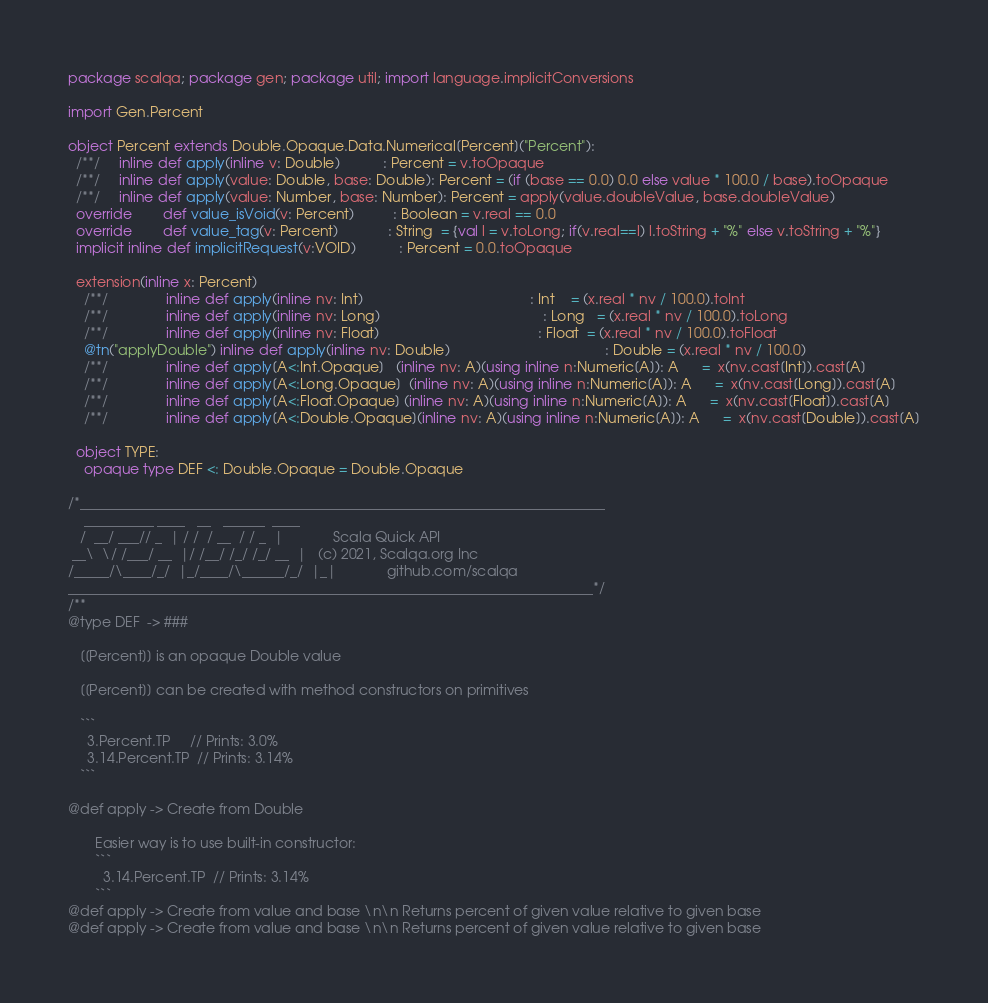<code> <loc_0><loc_0><loc_500><loc_500><_Scala_>package scalqa; package gen; package util; import language.implicitConversions

import Gen.Percent

object Percent extends Double.Opaque.Data.Numerical[Percent]("Percent"):
  /**/     inline def apply(inline v: Double)           : Percent = v.toOpaque
  /**/     inline def apply(value: Double, base: Double): Percent = (if (base == 0.0) 0.0 else value * 100.0 / base).toOpaque
  /**/     inline def apply(value: Number, base: Number): Percent = apply(value.doubleValue, base.doubleValue)
  override        def value_isVoid(v: Percent)          : Boolean = v.real == 0.0
  override        def value_tag(v: Percent)             : String  = {val l = v.toLong; if(v.real==l) l.toString + "%" else v.toString + "%"}
  implicit inline def implicitRequest(v:VOID)           : Percent = 0.0.toOpaque

  extension(inline x: Percent)
    /**/               inline def apply(inline nv: Int)                                           : Int    = (x.real * nv / 100.0).toInt
    /**/               inline def apply(inline nv: Long)                                          : Long   = (x.real * nv / 100.0).toLong
    /**/               inline def apply(inline nv: Float)                                         : Float  = (x.real * nv / 100.0).toFloat
    @tn("applyDouble") inline def apply(inline nv: Double)                                        : Double = (x.real * nv / 100.0)
    /**/               inline def apply[A<:Int.Opaque]   (inline nv: A)(using inline n:Numeric[A]): A      =  x(nv.cast[Int]).cast[A]
    /**/               inline def apply[A<:Long.Opaque]  (inline nv: A)(using inline n:Numeric[A]): A      =  x(nv.cast[Long]).cast[A]
    /**/               inline def apply[A<:Float.Opaque] (inline nv: A)(using inline n:Numeric[A]): A      =  x(nv.cast[Float]).cast[A]
    /**/               inline def apply[A<:Double.Opaque](inline nv: A)(using inline n:Numeric[A]): A      =  x(nv.cast[Double]).cast[A]

  object TYPE:
    opaque type DEF <: Double.Opaque = Double.Opaque

/*___________________________________________________________________________
    __________ ____   __   ______  ____
   /  __/ ___// _  | / /  / __  / / _  |             Scala Quick API
 __\  \/ /___/ __  |/ /__/ /_/ /_/ __  |   (c) 2021, Scalqa.org Inc
/_____/\____/_/  |_/____/\______/_/  |_|             github.com/scalqa
___________________________________________________________________________*/
/**
@type DEF  -> ###

   [[Percent]] is an opaque Double value

   [[Percent]] can be created with method constructors on primitives

   ```
     3.Percent.TP     // Prints: 3.0%
     3.14.Percent.TP  // Prints: 3.14%
   ```

@def apply -> Create from Double

       Easier way is to use built-in constructor:
       ```
         3.14.Percent.TP  // Prints: 3.14%
       ```
@def apply -> Create from value and base \n\n Returns percent of given value relative to given base
@def apply -> Create from value and base \n\n Returns percent of given value relative to given base
</code> 